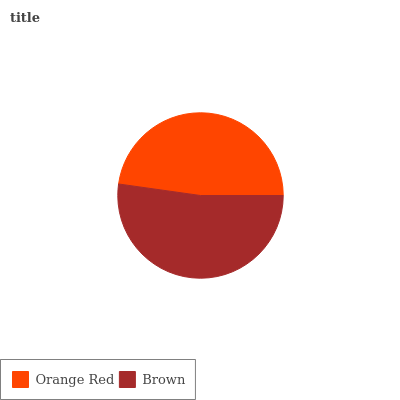Is Orange Red the minimum?
Answer yes or no. Yes. Is Brown the maximum?
Answer yes or no. Yes. Is Brown the minimum?
Answer yes or no. No. Is Brown greater than Orange Red?
Answer yes or no. Yes. Is Orange Red less than Brown?
Answer yes or no. Yes. Is Orange Red greater than Brown?
Answer yes or no. No. Is Brown less than Orange Red?
Answer yes or no. No. Is Brown the high median?
Answer yes or no. Yes. Is Orange Red the low median?
Answer yes or no. Yes. Is Orange Red the high median?
Answer yes or no. No. Is Brown the low median?
Answer yes or no. No. 